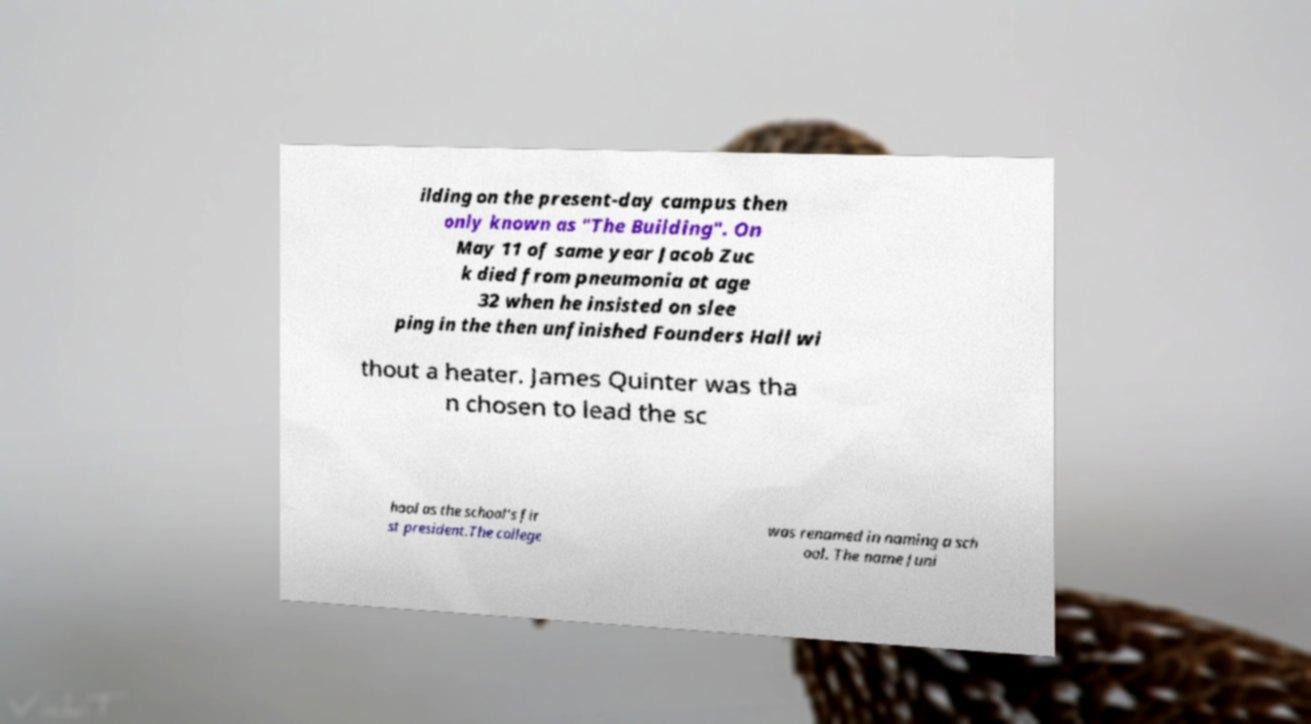Can you accurately transcribe the text from the provided image for me? ilding on the present-day campus then only known as "The Building". On May 11 of same year Jacob Zuc k died from pneumonia at age 32 when he insisted on slee ping in the then unfinished Founders Hall wi thout a heater. James Quinter was tha n chosen to lead the sc hool as the school's fir st president.The college was renamed in naming a sch ool. The name Juni 